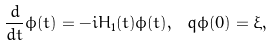<formula> <loc_0><loc_0><loc_500><loc_500>\frac { d } { d t } \phi ( t ) = - i H _ { 1 } ( t ) \phi ( t ) , \ q \phi ( 0 ) = \xi ,</formula> 